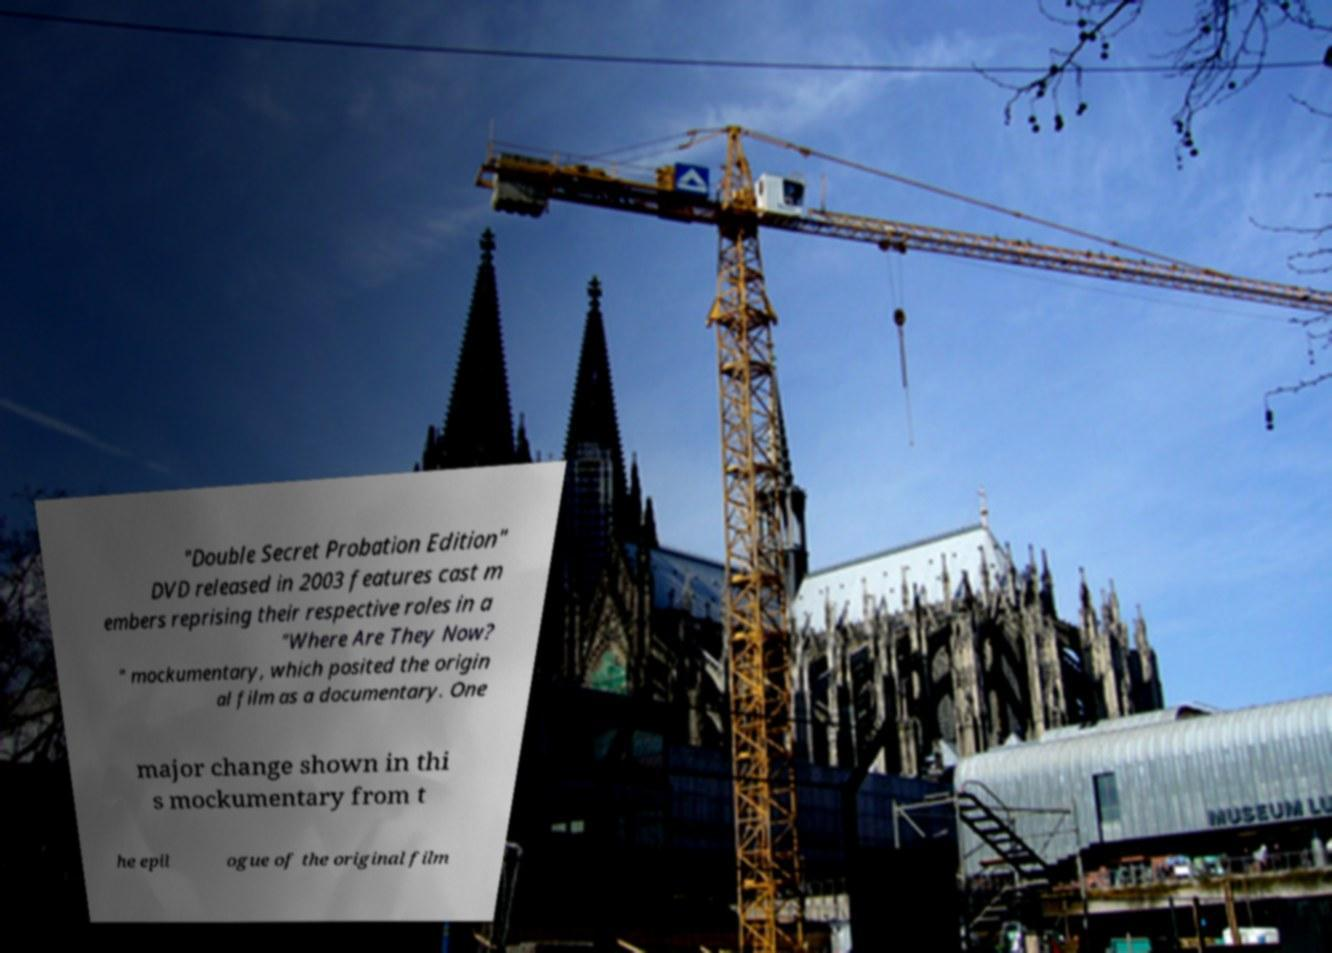For documentation purposes, I need the text within this image transcribed. Could you provide that? "Double Secret Probation Edition" DVD released in 2003 features cast m embers reprising their respective roles in a "Where Are They Now? " mockumentary, which posited the origin al film as a documentary. One major change shown in thi s mockumentary from t he epil ogue of the original film 